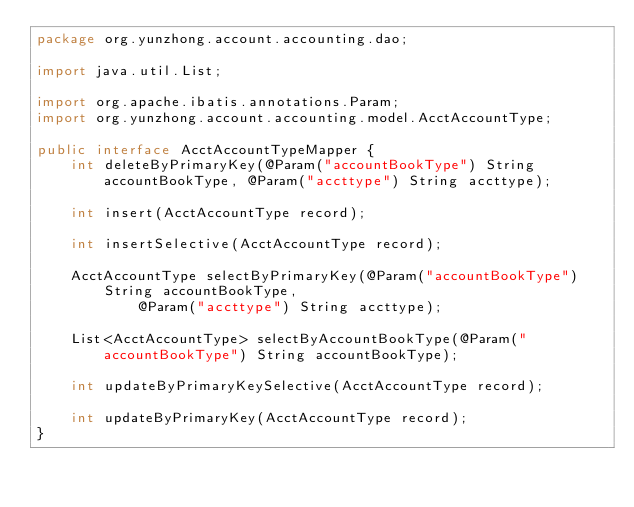<code> <loc_0><loc_0><loc_500><loc_500><_Java_>package org.yunzhong.account.accounting.dao;

import java.util.List;

import org.apache.ibatis.annotations.Param;
import org.yunzhong.account.accounting.model.AcctAccountType;

public interface AcctAccountTypeMapper {
    int deleteByPrimaryKey(@Param("accountBookType") String accountBookType, @Param("accttype") String accttype);

    int insert(AcctAccountType record);

    int insertSelective(AcctAccountType record);

    AcctAccountType selectByPrimaryKey(@Param("accountBookType") String accountBookType,
            @Param("accttype") String accttype);

    List<AcctAccountType> selectByAccountBookType(@Param("accountBookType") String accountBookType);

    int updateByPrimaryKeySelective(AcctAccountType record);

    int updateByPrimaryKey(AcctAccountType record);
}</code> 